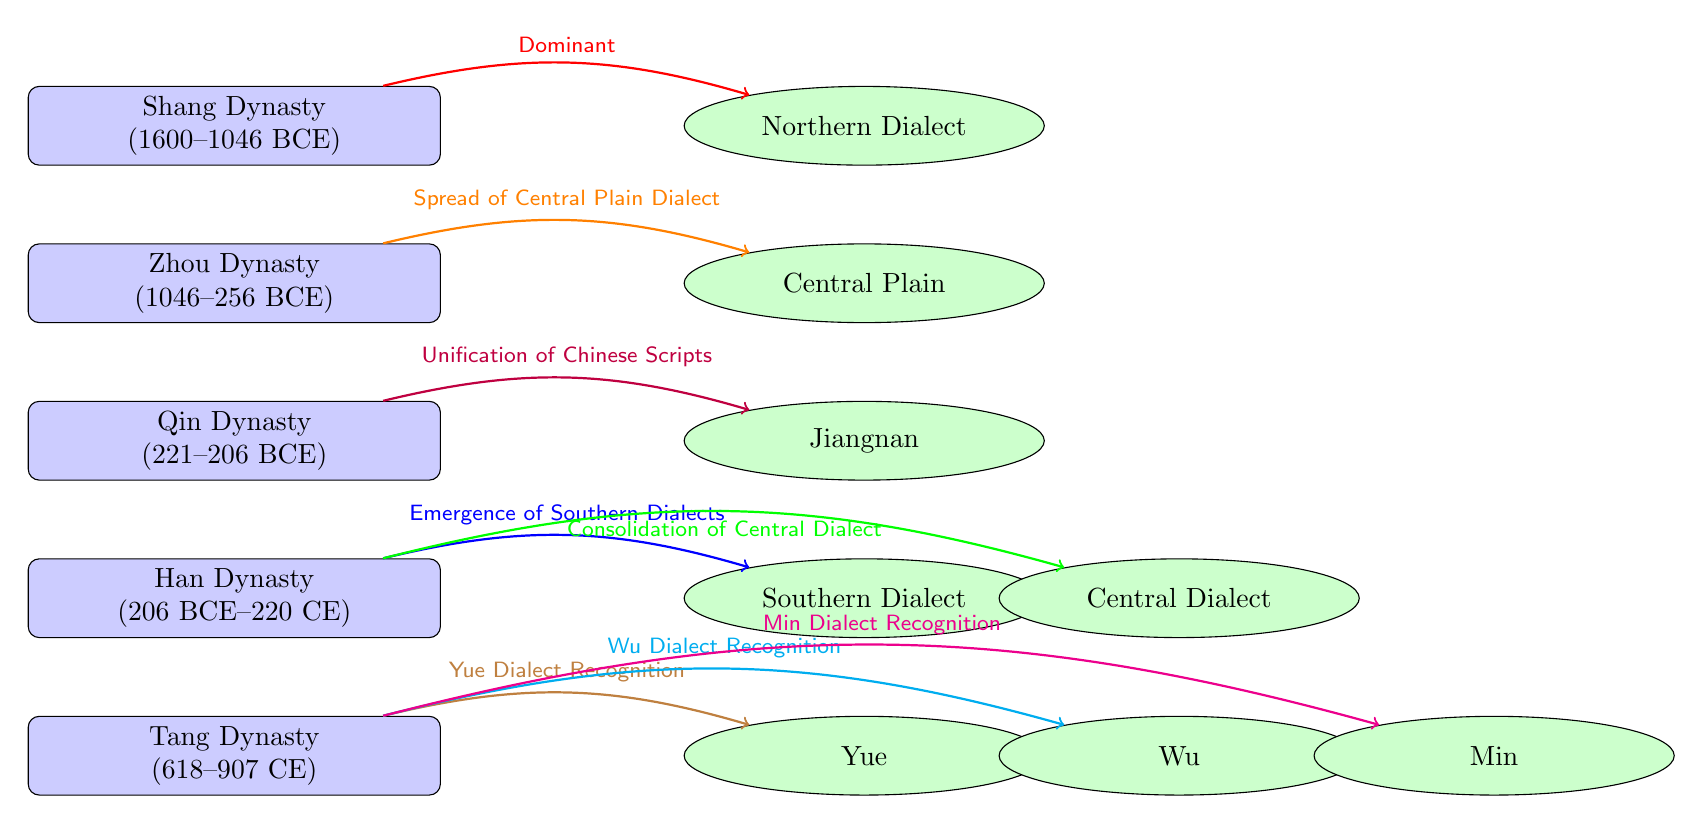What is the time period of the Shang Dynasty? The diagram specifies that the Shang Dynasty lasted from 1600 to 1046 BCE. By referring to the node labeled "Shang Dynasty," we can easily identify this timeframe directly from the text.
Answer: 1600--1046 BCE Which dialect is associated with the Han Dynasty? According to the diagram, the Han Dynasty is connected to two dialects: the "Southern Dialect" and the "Central Dialect." While both are linked to this dynasty, we focus on the key representation of Southern Dialects in the diagram.
Answer: Southern Dialect How many dialects are linked to the Tang Dynasty? The Tang Dynasty connects to three dialects: Yue, Wu, and Min. Counting the represented dialect nodes that originate from the Tang Dynasty leads us to this conclusion.
Answer: 3 What was the significant outcome of the Qin Dynasty? The connecting arrow indicates that the Qin Dynasty led to the "Unification of Chinese Scripts." This relationship between the Qin Dynasty and its effect on scripts is explicitly stated in the diagram.
Answer: Unification of Chinese Scripts Which dynasty is recognized for the emergence of the Yue dialect? The diagram shows an arrow from the Tang Dynasty directly to the recognition of the Yue dialect. We can thus conclude that the Tang Dynasty is the one associated with this emergence.
Answer: Tang Dynasty What is the dominant dialect during the Shang Dynasty? The arrow from the Shang Dynasty directly points to the "Northern Dialect," indicating it as the primary dialect during this period. This direct connection helps us identify the dominant dialect without ambiguity.
Answer: Northern Dialect Which dialect is recognized most recently according to the diagram? The arrows extending from the Tang Dynasty to its dialects suggest recognition of dialects in this era. Among these, the last mentioned dialect is "Min," indicating it's the most recently recognized.
Answer: Min Which connection indicates the spread of the Central Plain dialect? An orange arrow directs from the Zhou Dynasty to the "Central Plain," signifying this spread. By tracing this connection, we deduce the specific pathway of dialect evolution in this period.
Answer: Spread of Central Plain Dialect 